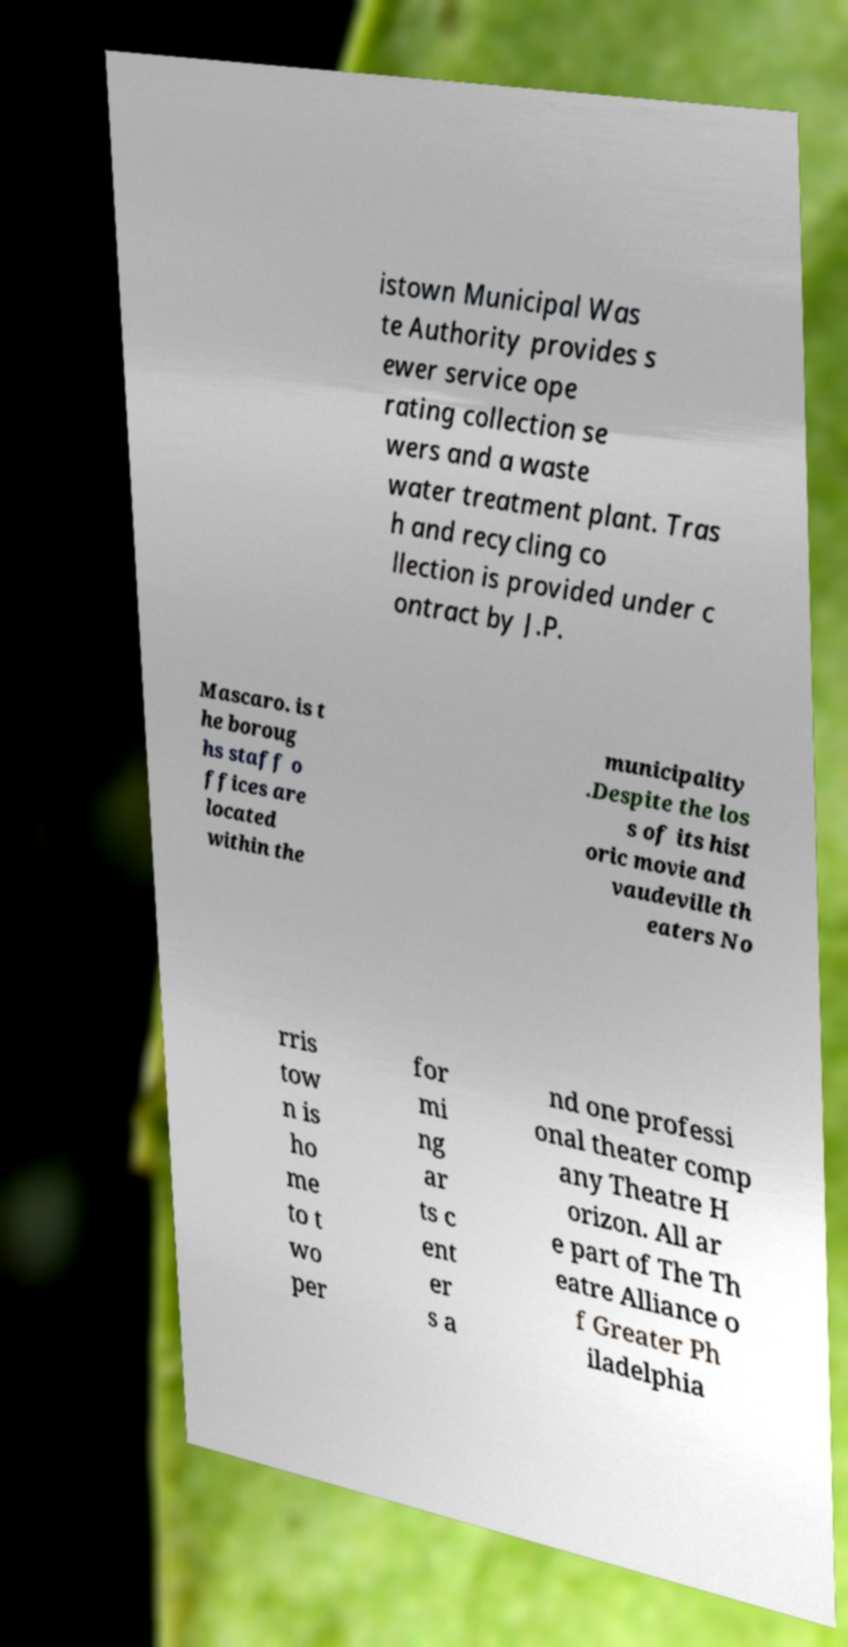Please identify and transcribe the text found in this image. istown Municipal Was te Authority provides s ewer service ope rating collection se wers and a waste water treatment plant. Tras h and recycling co llection is provided under c ontract by J.P. Mascaro. is t he boroug hs staff o ffices are located within the municipality .Despite the los s of its hist oric movie and vaudeville th eaters No rris tow n is ho me to t wo per for mi ng ar ts c ent er s a nd one professi onal theater comp any Theatre H orizon. All ar e part of The Th eatre Alliance o f Greater Ph iladelphia 